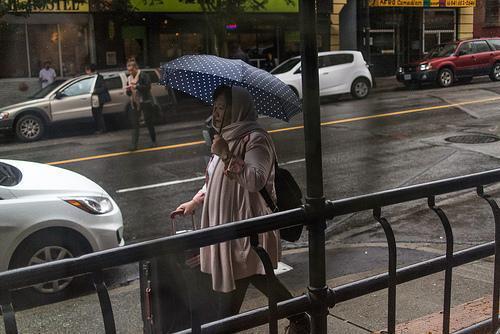How many people in photo?
Give a very brief answer. 4. 